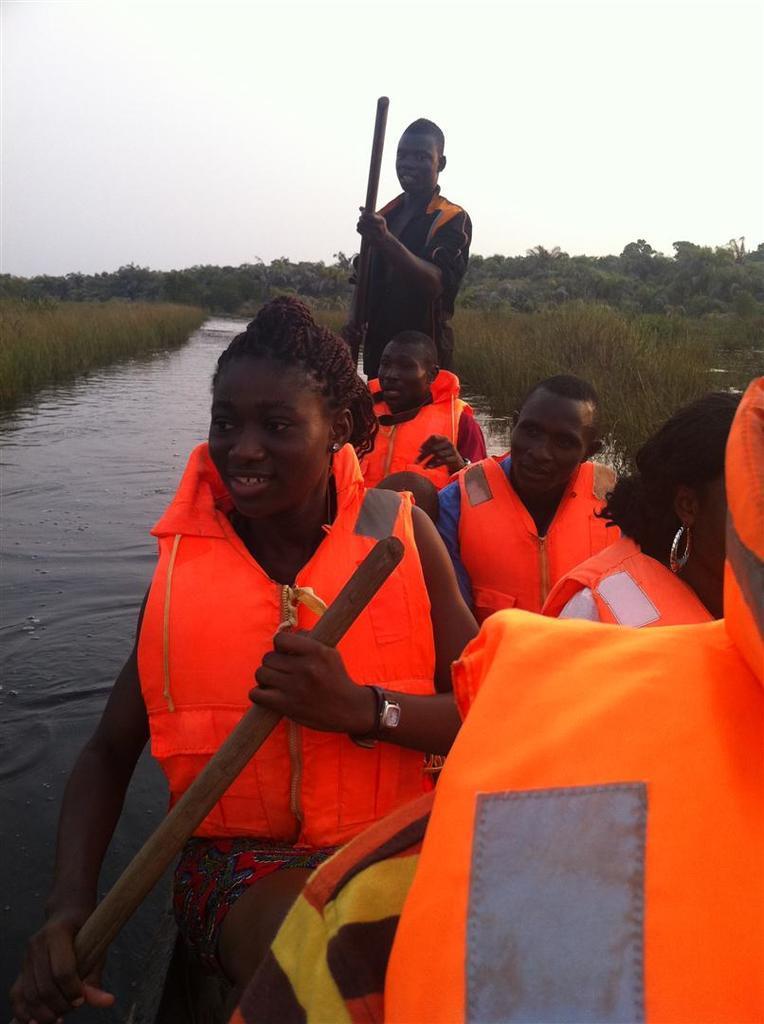Can you describe this image briefly? In this image we can see a few people wearing the safety jackets. We can also see a man standing and holding the wooden rod and these people are present in the boat which is on the surface of the water. Image also consists of trees and also the grass. Sky is also visible. 